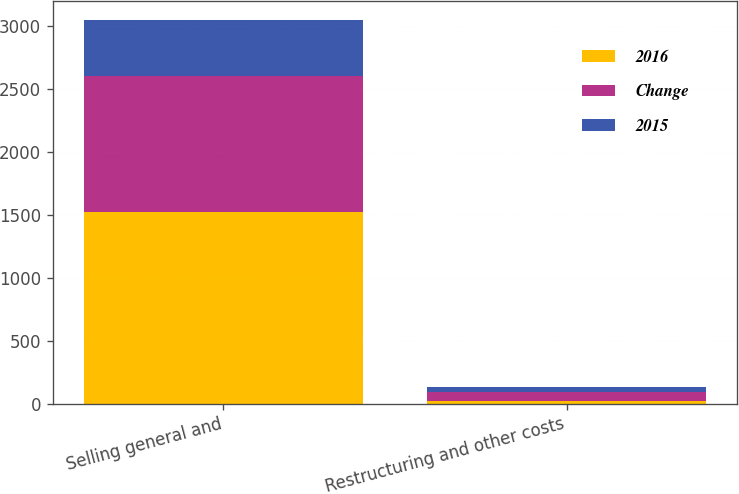Convert chart to OTSL. <chart><loc_0><loc_0><loc_500><loc_500><stacked_bar_chart><ecel><fcel>Selling general and<fcel>Restructuring and other costs<nl><fcel>2016<fcel>1523<fcel>23.2<nl><fcel>Change<fcel>1077.3<fcel>64.7<nl><fcel>2015<fcel>445.7<fcel>41.5<nl></chart> 